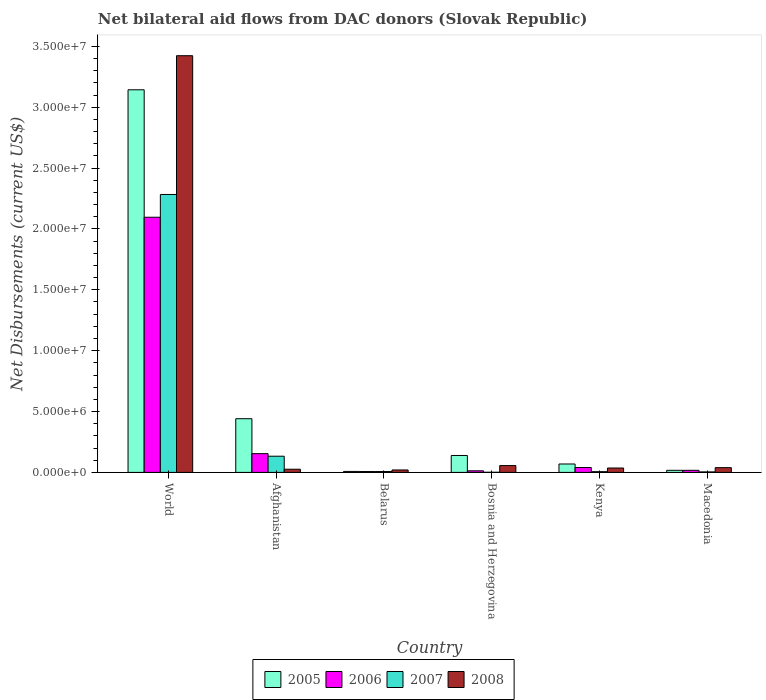How many different coloured bars are there?
Provide a short and direct response. 4. How many groups of bars are there?
Your response must be concise. 6. Are the number of bars per tick equal to the number of legend labels?
Give a very brief answer. Yes. Are the number of bars on each tick of the X-axis equal?
Offer a terse response. Yes. What is the label of the 2nd group of bars from the left?
Keep it short and to the point. Afghanistan. In how many cases, is the number of bars for a given country not equal to the number of legend labels?
Your answer should be very brief. 0. What is the net bilateral aid flows in 2005 in World?
Your answer should be very brief. 3.14e+07. Across all countries, what is the maximum net bilateral aid flows in 2008?
Offer a very short reply. 3.42e+07. In which country was the net bilateral aid flows in 2006 maximum?
Your answer should be very brief. World. In which country was the net bilateral aid flows in 2008 minimum?
Keep it short and to the point. Belarus. What is the total net bilateral aid flows in 2006 in the graph?
Your response must be concise. 2.33e+07. What is the difference between the net bilateral aid flows in 2007 in Bosnia and Herzegovina and that in World?
Make the answer very short. -2.28e+07. What is the difference between the net bilateral aid flows in 2005 in Macedonia and the net bilateral aid flows in 2008 in Belarus?
Provide a succinct answer. -3.00e+04. What is the average net bilateral aid flows in 2008 per country?
Offer a very short reply. 6.00e+06. What is the difference between the net bilateral aid flows of/in 2008 and net bilateral aid flows of/in 2005 in Kenya?
Provide a succinct answer. -3.30e+05. What is the ratio of the net bilateral aid flows in 2008 in Afghanistan to that in Bosnia and Herzegovina?
Provide a short and direct response. 0.46. What is the difference between the highest and the second highest net bilateral aid flows in 2005?
Your answer should be compact. 2.70e+07. What is the difference between the highest and the lowest net bilateral aid flows in 2005?
Your answer should be compact. 3.14e+07. In how many countries, is the net bilateral aid flows in 2007 greater than the average net bilateral aid flows in 2007 taken over all countries?
Offer a very short reply. 1. Is the sum of the net bilateral aid flows in 2008 in Afghanistan and Belarus greater than the maximum net bilateral aid flows in 2007 across all countries?
Provide a succinct answer. No. What does the 1st bar from the right in Kenya represents?
Provide a succinct answer. 2008. Is it the case that in every country, the sum of the net bilateral aid flows in 2008 and net bilateral aid flows in 2005 is greater than the net bilateral aid flows in 2006?
Give a very brief answer. Yes. Are the values on the major ticks of Y-axis written in scientific E-notation?
Your response must be concise. Yes. Does the graph contain any zero values?
Offer a very short reply. No. How many legend labels are there?
Provide a short and direct response. 4. What is the title of the graph?
Make the answer very short. Net bilateral aid flows from DAC donors (Slovak Republic). What is the label or title of the X-axis?
Your response must be concise. Country. What is the label or title of the Y-axis?
Ensure brevity in your answer.  Net Disbursements (current US$). What is the Net Disbursements (current US$) in 2005 in World?
Keep it short and to the point. 3.14e+07. What is the Net Disbursements (current US$) of 2006 in World?
Provide a short and direct response. 2.10e+07. What is the Net Disbursements (current US$) in 2007 in World?
Ensure brevity in your answer.  2.28e+07. What is the Net Disbursements (current US$) of 2008 in World?
Provide a succinct answer. 3.42e+07. What is the Net Disbursements (current US$) of 2005 in Afghanistan?
Provide a succinct answer. 4.41e+06. What is the Net Disbursements (current US$) of 2006 in Afghanistan?
Keep it short and to the point. 1.54e+06. What is the Net Disbursements (current US$) in 2007 in Afghanistan?
Provide a short and direct response. 1.33e+06. What is the Net Disbursements (current US$) of 2008 in Afghanistan?
Provide a succinct answer. 2.60e+05. What is the Net Disbursements (current US$) in 2008 in Belarus?
Offer a very short reply. 2.00e+05. What is the Net Disbursements (current US$) in 2005 in Bosnia and Herzegovina?
Your answer should be very brief. 1.39e+06. What is the Net Disbursements (current US$) in 2006 in Bosnia and Herzegovina?
Your response must be concise. 1.30e+05. What is the Net Disbursements (current US$) in 2007 in Bosnia and Herzegovina?
Offer a very short reply. 10000. What is the Net Disbursements (current US$) of 2008 in Bosnia and Herzegovina?
Provide a short and direct response. 5.60e+05. What is the Net Disbursements (current US$) of 2005 in Kenya?
Offer a very short reply. 6.90e+05. What is the Net Disbursements (current US$) in 2006 in Kenya?
Offer a very short reply. 4.00e+05. What is the Net Disbursements (current US$) in 2007 in Kenya?
Your answer should be compact. 6.00e+04. What is the Net Disbursements (current US$) of 2006 in Macedonia?
Give a very brief answer. 1.70e+05. Across all countries, what is the maximum Net Disbursements (current US$) in 2005?
Give a very brief answer. 3.14e+07. Across all countries, what is the maximum Net Disbursements (current US$) in 2006?
Make the answer very short. 2.10e+07. Across all countries, what is the maximum Net Disbursements (current US$) in 2007?
Your answer should be very brief. 2.28e+07. Across all countries, what is the maximum Net Disbursements (current US$) of 2008?
Offer a very short reply. 3.42e+07. Across all countries, what is the minimum Net Disbursements (current US$) of 2006?
Offer a very short reply. 7.00e+04. Across all countries, what is the minimum Net Disbursements (current US$) in 2007?
Your response must be concise. 10000. What is the total Net Disbursements (current US$) of 2005 in the graph?
Make the answer very short. 3.82e+07. What is the total Net Disbursements (current US$) of 2006 in the graph?
Offer a terse response. 2.33e+07. What is the total Net Disbursements (current US$) in 2007 in the graph?
Provide a short and direct response. 2.43e+07. What is the total Net Disbursements (current US$) of 2008 in the graph?
Your answer should be compact. 3.60e+07. What is the difference between the Net Disbursements (current US$) in 2005 in World and that in Afghanistan?
Your response must be concise. 2.70e+07. What is the difference between the Net Disbursements (current US$) in 2006 in World and that in Afghanistan?
Make the answer very short. 1.94e+07. What is the difference between the Net Disbursements (current US$) of 2007 in World and that in Afghanistan?
Ensure brevity in your answer.  2.15e+07. What is the difference between the Net Disbursements (current US$) of 2008 in World and that in Afghanistan?
Give a very brief answer. 3.40e+07. What is the difference between the Net Disbursements (current US$) of 2005 in World and that in Belarus?
Provide a succinct answer. 3.14e+07. What is the difference between the Net Disbursements (current US$) of 2006 in World and that in Belarus?
Your response must be concise. 2.09e+07. What is the difference between the Net Disbursements (current US$) of 2007 in World and that in Belarus?
Your response must be concise. 2.28e+07. What is the difference between the Net Disbursements (current US$) of 2008 in World and that in Belarus?
Ensure brevity in your answer.  3.40e+07. What is the difference between the Net Disbursements (current US$) of 2005 in World and that in Bosnia and Herzegovina?
Offer a very short reply. 3.00e+07. What is the difference between the Net Disbursements (current US$) in 2006 in World and that in Bosnia and Herzegovina?
Provide a succinct answer. 2.08e+07. What is the difference between the Net Disbursements (current US$) of 2007 in World and that in Bosnia and Herzegovina?
Provide a succinct answer. 2.28e+07. What is the difference between the Net Disbursements (current US$) of 2008 in World and that in Bosnia and Herzegovina?
Ensure brevity in your answer.  3.37e+07. What is the difference between the Net Disbursements (current US$) in 2005 in World and that in Kenya?
Give a very brief answer. 3.07e+07. What is the difference between the Net Disbursements (current US$) of 2006 in World and that in Kenya?
Provide a succinct answer. 2.06e+07. What is the difference between the Net Disbursements (current US$) of 2007 in World and that in Kenya?
Offer a very short reply. 2.28e+07. What is the difference between the Net Disbursements (current US$) of 2008 in World and that in Kenya?
Keep it short and to the point. 3.39e+07. What is the difference between the Net Disbursements (current US$) of 2005 in World and that in Macedonia?
Give a very brief answer. 3.13e+07. What is the difference between the Net Disbursements (current US$) of 2006 in World and that in Macedonia?
Offer a terse response. 2.08e+07. What is the difference between the Net Disbursements (current US$) in 2007 in World and that in Macedonia?
Your response must be concise. 2.28e+07. What is the difference between the Net Disbursements (current US$) in 2008 in World and that in Macedonia?
Ensure brevity in your answer.  3.38e+07. What is the difference between the Net Disbursements (current US$) in 2005 in Afghanistan and that in Belarus?
Keep it short and to the point. 4.33e+06. What is the difference between the Net Disbursements (current US$) of 2006 in Afghanistan and that in Belarus?
Make the answer very short. 1.47e+06. What is the difference between the Net Disbursements (current US$) in 2007 in Afghanistan and that in Belarus?
Offer a terse response. 1.26e+06. What is the difference between the Net Disbursements (current US$) in 2008 in Afghanistan and that in Belarus?
Your answer should be compact. 6.00e+04. What is the difference between the Net Disbursements (current US$) of 2005 in Afghanistan and that in Bosnia and Herzegovina?
Offer a very short reply. 3.02e+06. What is the difference between the Net Disbursements (current US$) in 2006 in Afghanistan and that in Bosnia and Herzegovina?
Offer a terse response. 1.41e+06. What is the difference between the Net Disbursements (current US$) in 2007 in Afghanistan and that in Bosnia and Herzegovina?
Keep it short and to the point. 1.32e+06. What is the difference between the Net Disbursements (current US$) in 2008 in Afghanistan and that in Bosnia and Herzegovina?
Ensure brevity in your answer.  -3.00e+05. What is the difference between the Net Disbursements (current US$) of 2005 in Afghanistan and that in Kenya?
Offer a terse response. 3.72e+06. What is the difference between the Net Disbursements (current US$) of 2006 in Afghanistan and that in Kenya?
Keep it short and to the point. 1.14e+06. What is the difference between the Net Disbursements (current US$) of 2007 in Afghanistan and that in Kenya?
Keep it short and to the point. 1.27e+06. What is the difference between the Net Disbursements (current US$) of 2005 in Afghanistan and that in Macedonia?
Offer a very short reply. 4.24e+06. What is the difference between the Net Disbursements (current US$) in 2006 in Afghanistan and that in Macedonia?
Keep it short and to the point. 1.37e+06. What is the difference between the Net Disbursements (current US$) of 2007 in Afghanistan and that in Macedonia?
Keep it short and to the point. 1.29e+06. What is the difference between the Net Disbursements (current US$) of 2008 in Afghanistan and that in Macedonia?
Your response must be concise. -1.30e+05. What is the difference between the Net Disbursements (current US$) of 2005 in Belarus and that in Bosnia and Herzegovina?
Your answer should be very brief. -1.31e+06. What is the difference between the Net Disbursements (current US$) of 2007 in Belarus and that in Bosnia and Herzegovina?
Offer a terse response. 6.00e+04. What is the difference between the Net Disbursements (current US$) in 2008 in Belarus and that in Bosnia and Herzegovina?
Provide a short and direct response. -3.60e+05. What is the difference between the Net Disbursements (current US$) in 2005 in Belarus and that in Kenya?
Make the answer very short. -6.10e+05. What is the difference between the Net Disbursements (current US$) in 2006 in Belarus and that in Kenya?
Make the answer very short. -3.30e+05. What is the difference between the Net Disbursements (current US$) in 2007 in Belarus and that in Kenya?
Offer a terse response. 10000. What is the difference between the Net Disbursements (current US$) in 2008 in Belarus and that in Kenya?
Offer a very short reply. -1.60e+05. What is the difference between the Net Disbursements (current US$) of 2005 in Belarus and that in Macedonia?
Keep it short and to the point. -9.00e+04. What is the difference between the Net Disbursements (current US$) in 2006 in Belarus and that in Macedonia?
Give a very brief answer. -1.00e+05. What is the difference between the Net Disbursements (current US$) of 2008 in Belarus and that in Macedonia?
Your answer should be compact. -1.90e+05. What is the difference between the Net Disbursements (current US$) in 2005 in Bosnia and Herzegovina and that in Kenya?
Provide a short and direct response. 7.00e+05. What is the difference between the Net Disbursements (current US$) of 2007 in Bosnia and Herzegovina and that in Kenya?
Give a very brief answer. -5.00e+04. What is the difference between the Net Disbursements (current US$) of 2008 in Bosnia and Herzegovina and that in Kenya?
Provide a short and direct response. 2.00e+05. What is the difference between the Net Disbursements (current US$) of 2005 in Bosnia and Herzegovina and that in Macedonia?
Your answer should be compact. 1.22e+06. What is the difference between the Net Disbursements (current US$) of 2008 in Bosnia and Herzegovina and that in Macedonia?
Offer a terse response. 1.70e+05. What is the difference between the Net Disbursements (current US$) of 2005 in Kenya and that in Macedonia?
Offer a terse response. 5.20e+05. What is the difference between the Net Disbursements (current US$) of 2008 in Kenya and that in Macedonia?
Provide a short and direct response. -3.00e+04. What is the difference between the Net Disbursements (current US$) in 2005 in World and the Net Disbursements (current US$) in 2006 in Afghanistan?
Your response must be concise. 2.99e+07. What is the difference between the Net Disbursements (current US$) of 2005 in World and the Net Disbursements (current US$) of 2007 in Afghanistan?
Your answer should be very brief. 3.01e+07. What is the difference between the Net Disbursements (current US$) of 2005 in World and the Net Disbursements (current US$) of 2008 in Afghanistan?
Your answer should be compact. 3.12e+07. What is the difference between the Net Disbursements (current US$) in 2006 in World and the Net Disbursements (current US$) in 2007 in Afghanistan?
Make the answer very short. 1.96e+07. What is the difference between the Net Disbursements (current US$) in 2006 in World and the Net Disbursements (current US$) in 2008 in Afghanistan?
Provide a succinct answer. 2.07e+07. What is the difference between the Net Disbursements (current US$) in 2007 in World and the Net Disbursements (current US$) in 2008 in Afghanistan?
Offer a very short reply. 2.26e+07. What is the difference between the Net Disbursements (current US$) of 2005 in World and the Net Disbursements (current US$) of 2006 in Belarus?
Offer a terse response. 3.14e+07. What is the difference between the Net Disbursements (current US$) in 2005 in World and the Net Disbursements (current US$) in 2007 in Belarus?
Offer a very short reply. 3.14e+07. What is the difference between the Net Disbursements (current US$) of 2005 in World and the Net Disbursements (current US$) of 2008 in Belarus?
Your answer should be very brief. 3.12e+07. What is the difference between the Net Disbursements (current US$) in 2006 in World and the Net Disbursements (current US$) in 2007 in Belarus?
Make the answer very short. 2.09e+07. What is the difference between the Net Disbursements (current US$) in 2006 in World and the Net Disbursements (current US$) in 2008 in Belarus?
Make the answer very short. 2.08e+07. What is the difference between the Net Disbursements (current US$) of 2007 in World and the Net Disbursements (current US$) of 2008 in Belarus?
Offer a very short reply. 2.26e+07. What is the difference between the Net Disbursements (current US$) in 2005 in World and the Net Disbursements (current US$) in 2006 in Bosnia and Herzegovina?
Your answer should be very brief. 3.13e+07. What is the difference between the Net Disbursements (current US$) in 2005 in World and the Net Disbursements (current US$) in 2007 in Bosnia and Herzegovina?
Your response must be concise. 3.14e+07. What is the difference between the Net Disbursements (current US$) in 2005 in World and the Net Disbursements (current US$) in 2008 in Bosnia and Herzegovina?
Offer a terse response. 3.09e+07. What is the difference between the Net Disbursements (current US$) in 2006 in World and the Net Disbursements (current US$) in 2007 in Bosnia and Herzegovina?
Give a very brief answer. 2.10e+07. What is the difference between the Net Disbursements (current US$) of 2006 in World and the Net Disbursements (current US$) of 2008 in Bosnia and Herzegovina?
Make the answer very short. 2.04e+07. What is the difference between the Net Disbursements (current US$) in 2007 in World and the Net Disbursements (current US$) in 2008 in Bosnia and Herzegovina?
Make the answer very short. 2.23e+07. What is the difference between the Net Disbursements (current US$) in 2005 in World and the Net Disbursements (current US$) in 2006 in Kenya?
Make the answer very short. 3.10e+07. What is the difference between the Net Disbursements (current US$) in 2005 in World and the Net Disbursements (current US$) in 2007 in Kenya?
Your answer should be compact. 3.14e+07. What is the difference between the Net Disbursements (current US$) of 2005 in World and the Net Disbursements (current US$) of 2008 in Kenya?
Make the answer very short. 3.11e+07. What is the difference between the Net Disbursements (current US$) in 2006 in World and the Net Disbursements (current US$) in 2007 in Kenya?
Offer a terse response. 2.09e+07. What is the difference between the Net Disbursements (current US$) in 2006 in World and the Net Disbursements (current US$) in 2008 in Kenya?
Give a very brief answer. 2.06e+07. What is the difference between the Net Disbursements (current US$) of 2007 in World and the Net Disbursements (current US$) of 2008 in Kenya?
Your answer should be compact. 2.25e+07. What is the difference between the Net Disbursements (current US$) of 2005 in World and the Net Disbursements (current US$) of 2006 in Macedonia?
Offer a terse response. 3.13e+07. What is the difference between the Net Disbursements (current US$) of 2005 in World and the Net Disbursements (current US$) of 2007 in Macedonia?
Your answer should be compact. 3.14e+07. What is the difference between the Net Disbursements (current US$) of 2005 in World and the Net Disbursements (current US$) of 2008 in Macedonia?
Give a very brief answer. 3.10e+07. What is the difference between the Net Disbursements (current US$) in 2006 in World and the Net Disbursements (current US$) in 2007 in Macedonia?
Offer a very short reply. 2.09e+07. What is the difference between the Net Disbursements (current US$) of 2006 in World and the Net Disbursements (current US$) of 2008 in Macedonia?
Provide a short and direct response. 2.06e+07. What is the difference between the Net Disbursements (current US$) of 2007 in World and the Net Disbursements (current US$) of 2008 in Macedonia?
Your response must be concise. 2.24e+07. What is the difference between the Net Disbursements (current US$) of 2005 in Afghanistan and the Net Disbursements (current US$) of 2006 in Belarus?
Provide a short and direct response. 4.34e+06. What is the difference between the Net Disbursements (current US$) in 2005 in Afghanistan and the Net Disbursements (current US$) in 2007 in Belarus?
Your answer should be very brief. 4.34e+06. What is the difference between the Net Disbursements (current US$) of 2005 in Afghanistan and the Net Disbursements (current US$) of 2008 in Belarus?
Provide a short and direct response. 4.21e+06. What is the difference between the Net Disbursements (current US$) in 2006 in Afghanistan and the Net Disbursements (current US$) in 2007 in Belarus?
Offer a terse response. 1.47e+06. What is the difference between the Net Disbursements (current US$) in 2006 in Afghanistan and the Net Disbursements (current US$) in 2008 in Belarus?
Your answer should be very brief. 1.34e+06. What is the difference between the Net Disbursements (current US$) of 2007 in Afghanistan and the Net Disbursements (current US$) of 2008 in Belarus?
Give a very brief answer. 1.13e+06. What is the difference between the Net Disbursements (current US$) in 2005 in Afghanistan and the Net Disbursements (current US$) in 2006 in Bosnia and Herzegovina?
Offer a very short reply. 4.28e+06. What is the difference between the Net Disbursements (current US$) in 2005 in Afghanistan and the Net Disbursements (current US$) in 2007 in Bosnia and Herzegovina?
Ensure brevity in your answer.  4.40e+06. What is the difference between the Net Disbursements (current US$) of 2005 in Afghanistan and the Net Disbursements (current US$) of 2008 in Bosnia and Herzegovina?
Give a very brief answer. 3.85e+06. What is the difference between the Net Disbursements (current US$) in 2006 in Afghanistan and the Net Disbursements (current US$) in 2007 in Bosnia and Herzegovina?
Your response must be concise. 1.53e+06. What is the difference between the Net Disbursements (current US$) of 2006 in Afghanistan and the Net Disbursements (current US$) of 2008 in Bosnia and Herzegovina?
Provide a succinct answer. 9.80e+05. What is the difference between the Net Disbursements (current US$) in 2007 in Afghanistan and the Net Disbursements (current US$) in 2008 in Bosnia and Herzegovina?
Offer a very short reply. 7.70e+05. What is the difference between the Net Disbursements (current US$) in 2005 in Afghanistan and the Net Disbursements (current US$) in 2006 in Kenya?
Your answer should be very brief. 4.01e+06. What is the difference between the Net Disbursements (current US$) in 2005 in Afghanistan and the Net Disbursements (current US$) in 2007 in Kenya?
Keep it short and to the point. 4.35e+06. What is the difference between the Net Disbursements (current US$) in 2005 in Afghanistan and the Net Disbursements (current US$) in 2008 in Kenya?
Offer a very short reply. 4.05e+06. What is the difference between the Net Disbursements (current US$) of 2006 in Afghanistan and the Net Disbursements (current US$) of 2007 in Kenya?
Offer a terse response. 1.48e+06. What is the difference between the Net Disbursements (current US$) in 2006 in Afghanistan and the Net Disbursements (current US$) in 2008 in Kenya?
Offer a terse response. 1.18e+06. What is the difference between the Net Disbursements (current US$) of 2007 in Afghanistan and the Net Disbursements (current US$) of 2008 in Kenya?
Keep it short and to the point. 9.70e+05. What is the difference between the Net Disbursements (current US$) of 2005 in Afghanistan and the Net Disbursements (current US$) of 2006 in Macedonia?
Offer a very short reply. 4.24e+06. What is the difference between the Net Disbursements (current US$) of 2005 in Afghanistan and the Net Disbursements (current US$) of 2007 in Macedonia?
Your answer should be compact. 4.37e+06. What is the difference between the Net Disbursements (current US$) of 2005 in Afghanistan and the Net Disbursements (current US$) of 2008 in Macedonia?
Give a very brief answer. 4.02e+06. What is the difference between the Net Disbursements (current US$) of 2006 in Afghanistan and the Net Disbursements (current US$) of 2007 in Macedonia?
Provide a short and direct response. 1.50e+06. What is the difference between the Net Disbursements (current US$) of 2006 in Afghanistan and the Net Disbursements (current US$) of 2008 in Macedonia?
Your answer should be very brief. 1.15e+06. What is the difference between the Net Disbursements (current US$) in 2007 in Afghanistan and the Net Disbursements (current US$) in 2008 in Macedonia?
Offer a terse response. 9.40e+05. What is the difference between the Net Disbursements (current US$) of 2005 in Belarus and the Net Disbursements (current US$) of 2008 in Bosnia and Herzegovina?
Give a very brief answer. -4.80e+05. What is the difference between the Net Disbursements (current US$) of 2006 in Belarus and the Net Disbursements (current US$) of 2007 in Bosnia and Herzegovina?
Give a very brief answer. 6.00e+04. What is the difference between the Net Disbursements (current US$) in 2006 in Belarus and the Net Disbursements (current US$) in 2008 in Bosnia and Herzegovina?
Provide a succinct answer. -4.90e+05. What is the difference between the Net Disbursements (current US$) in 2007 in Belarus and the Net Disbursements (current US$) in 2008 in Bosnia and Herzegovina?
Offer a very short reply. -4.90e+05. What is the difference between the Net Disbursements (current US$) of 2005 in Belarus and the Net Disbursements (current US$) of 2006 in Kenya?
Provide a short and direct response. -3.20e+05. What is the difference between the Net Disbursements (current US$) of 2005 in Belarus and the Net Disbursements (current US$) of 2007 in Kenya?
Your response must be concise. 2.00e+04. What is the difference between the Net Disbursements (current US$) in 2005 in Belarus and the Net Disbursements (current US$) in 2008 in Kenya?
Your response must be concise. -2.80e+05. What is the difference between the Net Disbursements (current US$) in 2005 in Belarus and the Net Disbursements (current US$) in 2006 in Macedonia?
Offer a terse response. -9.00e+04. What is the difference between the Net Disbursements (current US$) in 2005 in Belarus and the Net Disbursements (current US$) in 2007 in Macedonia?
Keep it short and to the point. 4.00e+04. What is the difference between the Net Disbursements (current US$) of 2005 in Belarus and the Net Disbursements (current US$) of 2008 in Macedonia?
Ensure brevity in your answer.  -3.10e+05. What is the difference between the Net Disbursements (current US$) of 2006 in Belarus and the Net Disbursements (current US$) of 2008 in Macedonia?
Make the answer very short. -3.20e+05. What is the difference between the Net Disbursements (current US$) in 2007 in Belarus and the Net Disbursements (current US$) in 2008 in Macedonia?
Offer a very short reply. -3.20e+05. What is the difference between the Net Disbursements (current US$) in 2005 in Bosnia and Herzegovina and the Net Disbursements (current US$) in 2006 in Kenya?
Your response must be concise. 9.90e+05. What is the difference between the Net Disbursements (current US$) of 2005 in Bosnia and Herzegovina and the Net Disbursements (current US$) of 2007 in Kenya?
Give a very brief answer. 1.33e+06. What is the difference between the Net Disbursements (current US$) in 2005 in Bosnia and Herzegovina and the Net Disbursements (current US$) in 2008 in Kenya?
Keep it short and to the point. 1.03e+06. What is the difference between the Net Disbursements (current US$) of 2007 in Bosnia and Herzegovina and the Net Disbursements (current US$) of 2008 in Kenya?
Your response must be concise. -3.50e+05. What is the difference between the Net Disbursements (current US$) in 2005 in Bosnia and Herzegovina and the Net Disbursements (current US$) in 2006 in Macedonia?
Your answer should be compact. 1.22e+06. What is the difference between the Net Disbursements (current US$) of 2005 in Bosnia and Herzegovina and the Net Disbursements (current US$) of 2007 in Macedonia?
Offer a terse response. 1.35e+06. What is the difference between the Net Disbursements (current US$) in 2006 in Bosnia and Herzegovina and the Net Disbursements (current US$) in 2007 in Macedonia?
Provide a short and direct response. 9.00e+04. What is the difference between the Net Disbursements (current US$) of 2006 in Bosnia and Herzegovina and the Net Disbursements (current US$) of 2008 in Macedonia?
Your answer should be compact. -2.60e+05. What is the difference between the Net Disbursements (current US$) of 2007 in Bosnia and Herzegovina and the Net Disbursements (current US$) of 2008 in Macedonia?
Ensure brevity in your answer.  -3.80e+05. What is the difference between the Net Disbursements (current US$) in 2005 in Kenya and the Net Disbursements (current US$) in 2006 in Macedonia?
Ensure brevity in your answer.  5.20e+05. What is the difference between the Net Disbursements (current US$) in 2005 in Kenya and the Net Disbursements (current US$) in 2007 in Macedonia?
Keep it short and to the point. 6.50e+05. What is the difference between the Net Disbursements (current US$) of 2005 in Kenya and the Net Disbursements (current US$) of 2008 in Macedonia?
Ensure brevity in your answer.  3.00e+05. What is the difference between the Net Disbursements (current US$) of 2006 in Kenya and the Net Disbursements (current US$) of 2008 in Macedonia?
Offer a terse response. 10000. What is the difference between the Net Disbursements (current US$) in 2007 in Kenya and the Net Disbursements (current US$) in 2008 in Macedonia?
Your response must be concise. -3.30e+05. What is the average Net Disbursements (current US$) of 2005 per country?
Make the answer very short. 6.36e+06. What is the average Net Disbursements (current US$) in 2006 per country?
Offer a terse response. 3.88e+06. What is the average Net Disbursements (current US$) of 2007 per country?
Your answer should be compact. 4.06e+06. What is the average Net Disbursements (current US$) in 2008 per country?
Offer a terse response. 6.00e+06. What is the difference between the Net Disbursements (current US$) of 2005 and Net Disbursements (current US$) of 2006 in World?
Keep it short and to the point. 1.05e+07. What is the difference between the Net Disbursements (current US$) of 2005 and Net Disbursements (current US$) of 2007 in World?
Offer a very short reply. 8.60e+06. What is the difference between the Net Disbursements (current US$) in 2005 and Net Disbursements (current US$) in 2008 in World?
Provide a succinct answer. -2.80e+06. What is the difference between the Net Disbursements (current US$) in 2006 and Net Disbursements (current US$) in 2007 in World?
Provide a succinct answer. -1.87e+06. What is the difference between the Net Disbursements (current US$) of 2006 and Net Disbursements (current US$) of 2008 in World?
Your answer should be compact. -1.33e+07. What is the difference between the Net Disbursements (current US$) of 2007 and Net Disbursements (current US$) of 2008 in World?
Keep it short and to the point. -1.14e+07. What is the difference between the Net Disbursements (current US$) of 2005 and Net Disbursements (current US$) of 2006 in Afghanistan?
Provide a succinct answer. 2.87e+06. What is the difference between the Net Disbursements (current US$) of 2005 and Net Disbursements (current US$) of 2007 in Afghanistan?
Make the answer very short. 3.08e+06. What is the difference between the Net Disbursements (current US$) in 2005 and Net Disbursements (current US$) in 2008 in Afghanistan?
Ensure brevity in your answer.  4.15e+06. What is the difference between the Net Disbursements (current US$) of 2006 and Net Disbursements (current US$) of 2008 in Afghanistan?
Keep it short and to the point. 1.28e+06. What is the difference between the Net Disbursements (current US$) in 2007 and Net Disbursements (current US$) in 2008 in Afghanistan?
Offer a very short reply. 1.07e+06. What is the difference between the Net Disbursements (current US$) of 2005 and Net Disbursements (current US$) of 2007 in Belarus?
Ensure brevity in your answer.  10000. What is the difference between the Net Disbursements (current US$) in 2006 and Net Disbursements (current US$) in 2008 in Belarus?
Give a very brief answer. -1.30e+05. What is the difference between the Net Disbursements (current US$) of 2007 and Net Disbursements (current US$) of 2008 in Belarus?
Offer a very short reply. -1.30e+05. What is the difference between the Net Disbursements (current US$) in 2005 and Net Disbursements (current US$) in 2006 in Bosnia and Herzegovina?
Provide a short and direct response. 1.26e+06. What is the difference between the Net Disbursements (current US$) in 2005 and Net Disbursements (current US$) in 2007 in Bosnia and Herzegovina?
Offer a very short reply. 1.38e+06. What is the difference between the Net Disbursements (current US$) in 2005 and Net Disbursements (current US$) in 2008 in Bosnia and Herzegovina?
Offer a terse response. 8.30e+05. What is the difference between the Net Disbursements (current US$) in 2006 and Net Disbursements (current US$) in 2008 in Bosnia and Herzegovina?
Ensure brevity in your answer.  -4.30e+05. What is the difference between the Net Disbursements (current US$) of 2007 and Net Disbursements (current US$) of 2008 in Bosnia and Herzegovina?
Offer a very short reply. -5.50e+05. What is the difference between the Net Disbursements (current US$) in 2005 and Net Disbursements (current US$) in 2007 in Kenya?
Provide a succinct answer. 6.30e+05. What is the difference between the Net Disbursements (current US$) of 2006 and Net Disbursements (current US$) of 2007 in Kenya?
Provide a short and direct response. 3.40e+05. What is the difference between the Net Disbursements (current US$) of 2006 and Net Disbursements (current US$) of 2008 in Kenya?
Give a very brief answer. 4.00e+04. What is the difference between the Net Disbursements (current US$) of 2007 and Net Disbursements (current US$) of 2008 in Kenya?
Provide a succinct answer. -3.00e+05. What is the difference between the Net Disbursements (current US$) of 2007 and Net Disbursements (current US$) of 2008 in Macedonia?
Make the answer very short. -3.50e+05. What is the ratio of the Net Disbursements (current US$) in 2005 in World to that in Afghanistan?
Ensure brevity in your answer.  7.13. What is the ratio of the Net Disbursements (current US$) in 2006 in World to that in Afghanistan?
Offer a terse response. 13.61. What is the ratio of the Net Disbursements (current US$) of 2007 in World to that in Afghanistan?
Your answer should be compact. 17.17. What is the ratio of the Net Disbursements (current US$) of 2008 in World to that in Afghanistan?
Give a very brief answer. 131.65. What is the ratio of the Net Disbursements (current US$) of 2005 in World to that in Belarus?
Provide a short and direct response. 392.88. What is the ratio of the Net Disbursements (current US$) in 2006 in World to that in Belarus?
Give a very brief answer. 299.43. What is the ratio of the Net Disbursements (current US$) of 2007 in World to that in Belarus?
Offer a very short reply. 326.14. What is the ratio of the Net Disbursements (current US$) of 2008 in World to that in Belarus?
Provide a succinct answer. 171.15. What is the ratio of the Net Disbursements (current US$) of 2005 in World to that in Bosnia and Herzegovina?
Offer a terse response. 22.61. What is the ratio of the Net Disbursements (current US$) of 2006 in World to that in Bosnia and Herzegovina?
Provide a short and direct response. 161.23. What is the ratio of the Net Disbursements (current US$) of 2007 in World to that in Bosnia and Herzegovina?
Provide a succinct answer. 2283. What is the ratio of the Net Disbursements (current US$) in 2008 in World to that in Bosnia and Herzegovina?
Ensure brevity in your answer.  61.12. What is the ratio of the Net Disbursements (current US$) in 2005 in World to that in Kenya?
Your answer should be compact. 45.55. What is the ratio of the Net Disbursements (current US$) of 2006 in World to that in Kenya?
Ensure brevity in your answer.  52.4. What is the ratio of the Net Disbursements (current US$) of 2007 in World to that in Kenya?
Keep it short and to the point. 380.5. What is the ratio of the Net Disbursements (current US$) of 2008 in World to that in Kenya?
Your answer should be very brief. 95.08. What is the ratio of the Net Disbursements (current US$) of 2005 in World to that in Macedonia?
Offer a terse response. 184.88. What is the ratio of the Net Disbursements (current US$) of 2006 in World to that in Macedonia?
Make the answer very short. 123.29. What is the ratio of the Net Disbursements (current US$) of 2007 in World to that in Macedonia?
Keep it short and to the point. 570.75. What is the ratio of the Net Disbursements (current US$) in 2008 in World to that in Macedonia?
Ensure brevity in your answer.  87.77. What is the ratio of the Net Disbursements (current US$) in 2005 in Afghanistan to that in Belarus?
Your response must be concise. 55.12. What is the ratio of the Net Disbursements (current US$) of 2006 in Afghanistan to that in Belarus?
Provide a succinct answer. 22. What is the ratio of the Net Disbursements (current US$) of 2007 in Afghanistan to that in Belarus?
Give a very brief answer. 19. What is the ratio of the Net Disbursements (current US$) in 2008 in Afghanistan to that in Belarus?
Your answer should be very brief. 1.3. What is the ratio of the Net Disbursements (current US$) of 2005 in Afghanistan to that in Bosnia and Herzegovina?
Provide a short and direct response. 3.17. What is the ratio of the Net Disbursements (current US$) in 2006 in Afghanistan to that in Bosnia and Herzegovina?
Offer a terse response. 11.85. What is the ratio of the Net Disbursements (current US$) of 2007 in Afghanistan to that in Bosnia and Herzegovina?
Give a very brief answer. 133. What is the ratio of the Net Disbursements (current US$) in 2008 in Afghanistan to that in Bosnia and Herzegovina?
Provide a succinct answer. 0.46. What is the ratio of the Net Disbursements (current US$) of 2005 in Afghanistan to that in Kenya?
Your answer should be compact. 6.39. What is the ratio of the Net Disbursements (current US$) of 2006 in Afghanistan to that in Kenya?
Your response must be concise. 3.85. What is the ratio of the Net Disbursements (current US$) in 2007 in Afghanistan to that in Kenya?
Provide a short and direct response. 22.17. What is the ratio of the Net Disbursements (current US$) in 2008 in Afghanistan to that in Kenya?
Ensure brevity in your answer.  0.72. What is the ratio of the Net Disbursements (current US$) of 2005 in Afghanistan to that in Macedonia?
Give a very brief answer. 25.94. What is the ratio of the Net Disbursements (current US$) in 2006 in Afghanistan to that in Macedonia?
Offer a terse response. 9.06. What is the ratio of the Net Disbursements (current US$) of 2007 in Afghanistan to that in Macedonia?
Give a very brief answer. 33.25. What is the ratio of the Net Disbursements (current US$) in 2008 in Afghanistan to that in Macedonia?
Make the answer very short. 0.67. What is the ratio of the Net Disbursements (current US$) in 2005 in Belarus to that in Bosnia and Herzegovina?
Your answer should be compact. 0.06. What is the ratio of the Net Disbursements (current US$) in 2006 in Belarus to that in Bosnia and Herzegovina?
Your answer should be compact. 0.54. What is the ratio of the Net Disbursements (current US$) in 2008 in Belarus to that in Bosnia and Herzegovina?
Provide a short and direct response. 0.36. What is the ratio of the Net Disbursements (current US$) of 2005 in Belarus to that in Kenya?
Your response must be concise. 0.12. What is the ratio of the Net Disbursements (current US$) of 2006 in Belarus to that in Kenya?
Your response must be concise. 0.17. What is the ratio of the Net Disbursements (current US$) of 2007 in Belarus to that in Kenya?
Your answer should be very brief. 1.17. What is the ratio of the Net Disbursements (current US$) of 2008 in Belarus to that in Kenya?
Provide a short and direct response. 0.56. What is the ratio of the Net Disbursements (current US$) of 2005 in Belarus to that in Macedonia?
Your answer should be very brief. 0.47. What is the ratio of the Net Disbursements (current US$) in 2006 in Belarus to that in Macedonia?
Your answer should be very brief. 0.41. What is the ratio of the Net Disbursements (current US$) in 2008 in Belarus to that in Macedonia?
Offer a terse response. 0.51. What is the ratio of the Net Disbursements (current US$) in 2005 in Bosnia and Herzegovina to that in Kenya?
Provide a short and direct response. 2.01. What is the ratio of the Net Disbursements (current US$) of 2006 in Bosnia and Herzegovina to that in Kenya?
Provide a succinct answer. 0.33. What is the ratio of the Net Disbursements (current US$) of 2007 in Bosnia and Herzegovina to that in Kenya?
Your answer should be compact. 0.17. What is the ratio of the Net Disbursements (current US$) of 2008 in Bosnia and Herzegovina to that in Kenya?
Your answer should be compact. 1.56. What is the ratio of the Net Disbursements (current US$) in 2005 in Bosnia and Herzegovina to that in Macedonia?
Your answer should be very brief. 8.18. What is the ratio of the Net Disbursements (current US$) in 2006 in Bosnia and Herzegovina to that in Macedonia?
Offer a terse response. 0.76. What is the ratio of the Net Disbursements (current US$) in 2007 in Bosnia and Herzegovina to that in Macedonia?
Provide a short and direct response. 0.25. What is the ratio of the Net Disbursements (current US$) in 2008 in Bosnia and Herzegovina to that in Macedonia?
Provide a succinct answer. 1.44. What is the ratio of the Net Disbursements (current US$) of 2005 in Kenya to that in Macedonia?
Your response must be concise. 4.06. What is the ratio of the Net Disbursements (current US$) in 2006 in Kenya to that in Macedonia?
Provide a short and direct response. 2.35. What is the difference between the highest and the second highest Net Disbursements (current US$) in 2005?
Offer a very short reply. 2.70e+07. What is the difference between the highest and the second highest Net Disbursements (current US$) of 2006?
Offer a very short reply. 1.94e+07. What is the difference between the highest and the second highest Net Disbursements (current US$) in 2007?
Ensure brevity in your answer.  2.15e+07. What is the difference between the highest and the second highest Net Disbursements (current US$) of 2008?
Keep it short and to the point. 3.37e+07. What is the difference between the highest and the lowest Net Disbursements (current US$) in 2005?
Offer a very short reply. 3.14e+07. What is the difference between the highest and the lowest Net Disbursements (current US$) of 2006?
Give a very brief answer. 2.09e+07. What is the difference between the highest and the lowest Net Disbursements (current US$) of 2007?
Provide a succinct answer. 2.28e+07. What is the difference between the highest and the lowest Net Disbursements (current US$) of 2008?
Provide a succinct answer. 3.40e+07. 